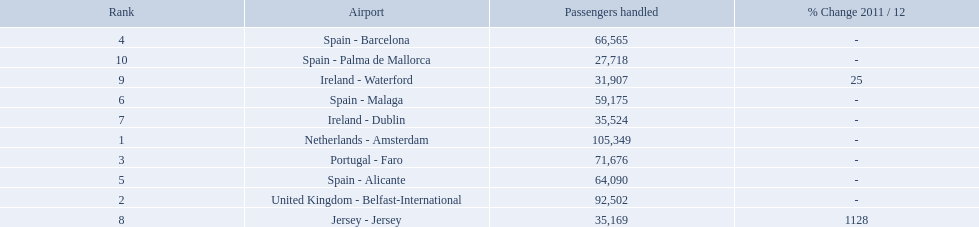What are the names of all the airports? Netherlands - Amsterdam, United Kingdom - Belfast-International, Portugal - Faro, Spain - Barcelona, Spain - Alicante, Spain - Malaga, Ireland - Dublin, Jersey - Jersey, Ireland - Waterford, Spain - Palma de Mallorca. Of these, what are all the passenger counts? 105,349, 92,502, 71,676, 66,565, 64,090, 59,175, 35,524, 35,169, 31,907, 27,718. Of these, which airport had more passengers than the united kingdom? Netherlands - Amsterdam. Which airports had passengers going through london southend airport? Netherlands - Amsterdam, United Kingdom - Belfast-International, Portugal - Faro, Spain - Barcelona, Spain - Alicante, Spain - Malaga, Ireland - Dublin, Jersey - Jersey, Ireland - Waterford, Spain - Palma de Mallorca. Of those airports, which airport had the least amount of passengers going through london southend airport? Spain - Palma de Mallorca. I'm looking to parse the entire table for insights. Could you assist me with that? {'header': ['Rank', 'Airport', 'Passengers handled', '% Change 2011 / 12'], 'rows': [['4', 'Spain - Barcelona', '66,565', '-'], ['10', 'Spain - Palma de Mallorca', '27,718', '-'], ['9', 'Ireland - Waterford', '31,907', '25'], ['6', 'Spain - Malaga', '59,175', '-'], ['7', 'Ireland - Dublin', '35,524', '-'], ['1', 'Netherlands - Amsterdam', '105,349', '-'], ['3', 'Portugal - Faro', '71,676', '-'], ['5', 'Spain - Alicante', '64,090', '-'], ['2', 'United Kingdom - Belfast-International', '92,502', '-'], ['8', 'Jersey - Jersey', '35,169', '1128']]} How many passengers did the united kingdom handle? 92,502. Who handled more passengers than this? Netherlands - Amsterdam. 